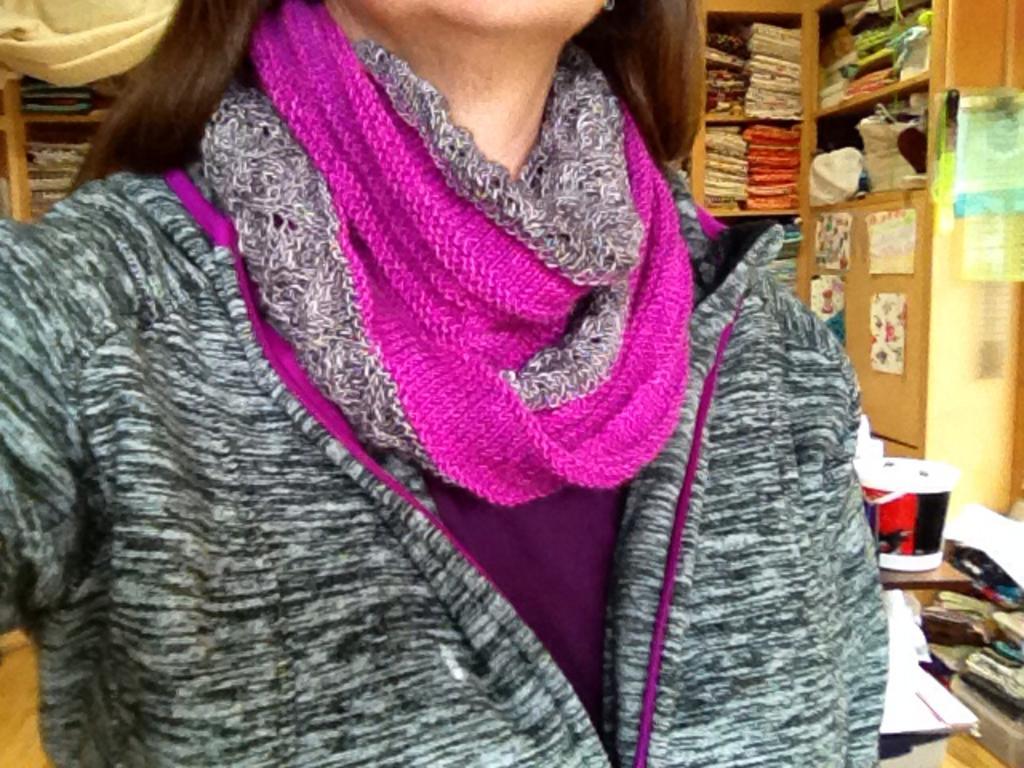Could you give a brief overview of what you see in this image? In this image we can see a person truncated, behind her we can see some shelves with objects, there are some posters with images and other objects. 